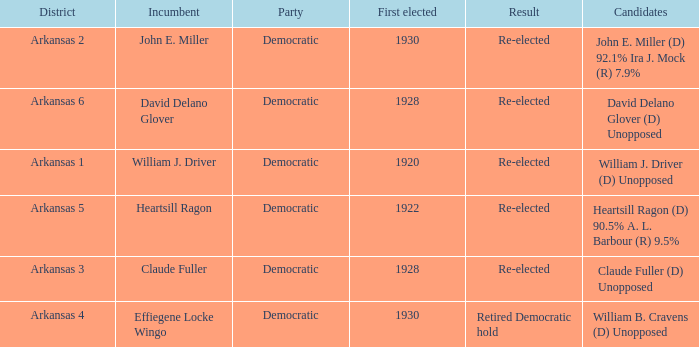How many districts had david delano glover as their incumbent representative? 1.0. 